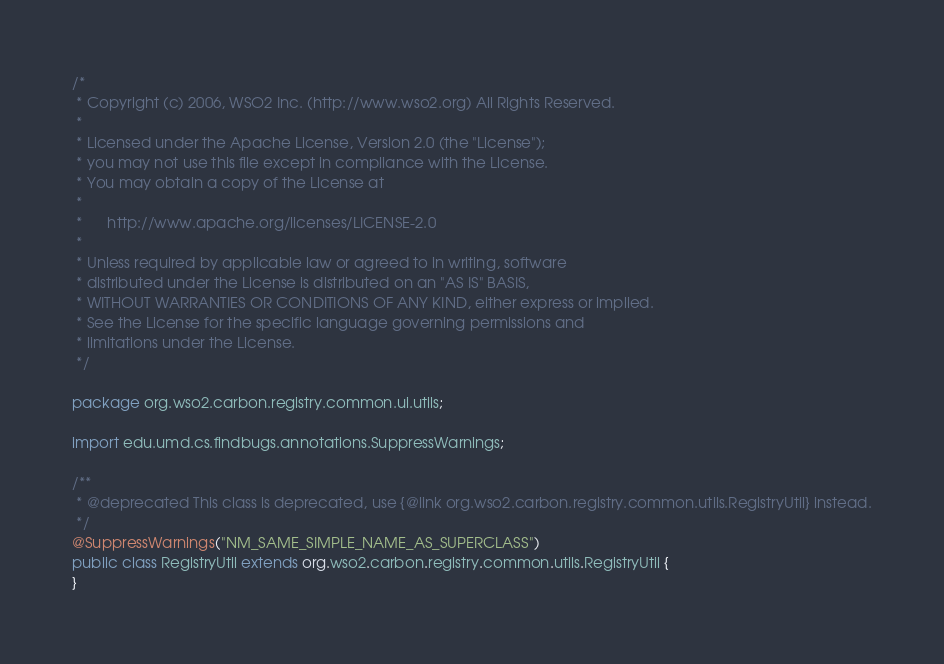<code> <loc_0><loc_0><loc_500><loc_500><_Java_>/*
 * Copyright (c) 2006, WSO2 Inc. (http://www.wso2.org) All Rights Reserved.
 *
 * Licensed under the Apache License, Version 2.0 (the "License");
 * you may not use this file except in compliance with the License.
 * You may obtain a copy of the License at
 *
 *      http://www.apache.org/licenses/LICENSE-2.0
 *
 * Unless required by applicable law or agreed to in writing, software
 * distributed under the License is distributed on an "AS IS" BASIS,
 * WITHOUT WARRANTIES OR CONDITIONS OF ANY KIND, either express or implied.
 * See the License for the specific language governing permissions and
 * limitations under the License.
 */

package org.wso2.carbon.registry.common.ui.utils;

import edu.umd.cs.findbugs.annotations.SuppressWarnings;

/**
 * @deprecated This class is deprecated, use {@link org.wso2.carbon.registry.common.utils.RegistryUtil} instead.
 */
@SuppressWarnings("NM_SAME_SIMPLE_NAME_AS_SUPERCLASS")
public class RegistryUtil extends org.wso2.carbon.registry.common.utils.RegistryUtil {
}
</code> 